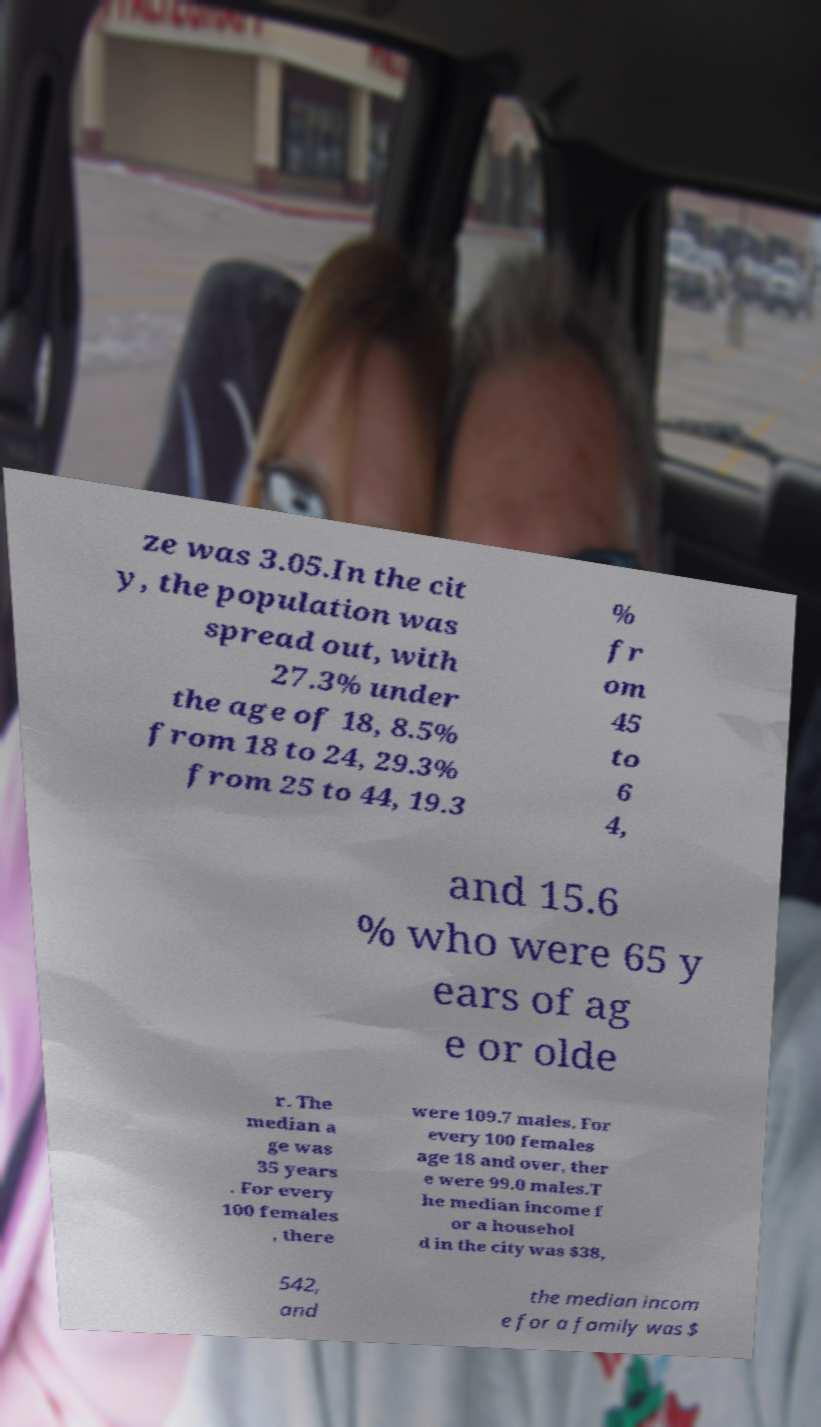There's text embedded in this image that I need extracted. Can you transcribe it verbatim? ze was 3.05.In the cit y, the population was spread out, with 27.3% under the age of 18, 8.5% from 18 to 24, 29.3% from 25 to 44, 19.3 % fr om 45 to 6 4, and 15.6 % who were 65 y ears of ag e or olde r. The median a ge was 35 years . For every 100 females , there were 109.7 males. For every 100 females age 18 and over, ther e were 99.0 males.T he median income f or a househol d in the city was $38, 542, and the median incom e for a family was $ 